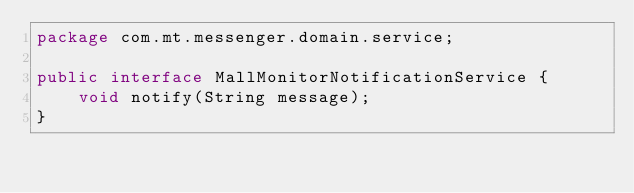<code> <loc_0><loc_0><loc_500><loc_500><_Java_>package com.mt.messenger.domain.service;

public interface MallMonitorNotificationService {
    void notify(String message);
}
</code> 